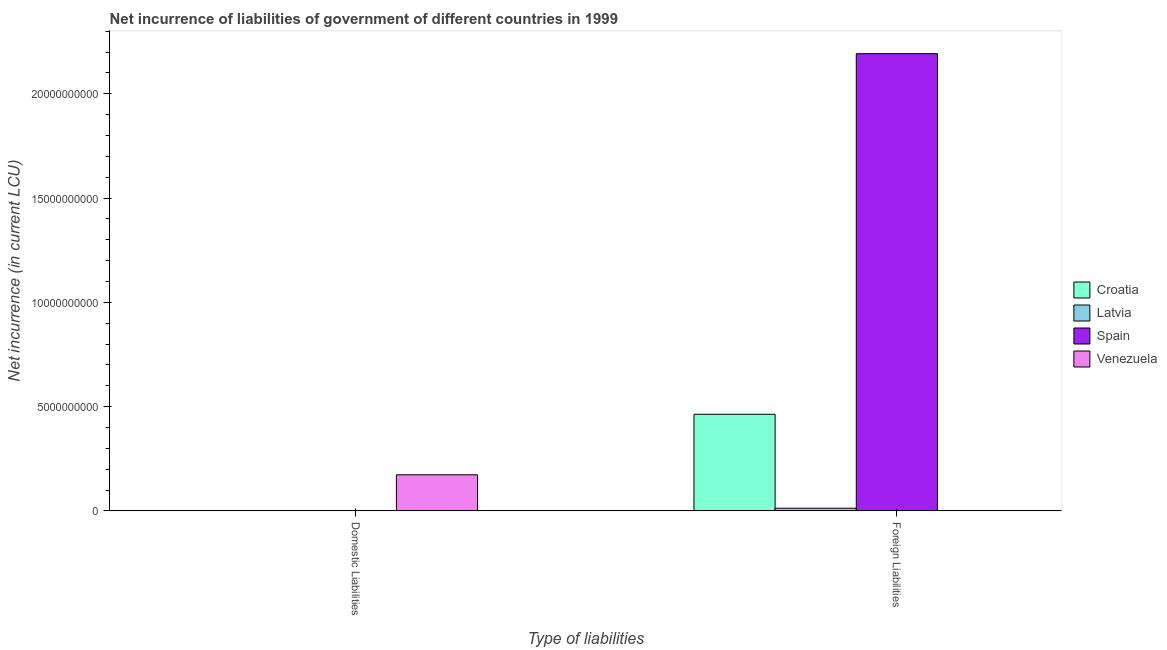How many different coloured bars are there?
Offer a very short reply. 4. Are the number of bars per tick equal to the number of legend labels?
Provide a succinct answer. No. What is the label of the 2nd group of bars from the left?
Your answer should be very brief. Foreign Liabilities. What is the net incurrence of foreign liabilities in Spain?
Provide a short and direct response. 2.19e+1. Across all countries, what is the maximum net incurrence of foreign liabilities?
Your answer should be compact. 2.19e+1. In which country was the net incurrence of domestic liabilities maximum?
Offer a very short reply. Venezuela. What is the total net incurrence of domestic liabilities in the graph?
Your answer should be very brief. 1.73e+09. What is the difference between the net incurrence of foreign liabilities in Latvia and that in Croatia?
Offer a very short reply. -4.50e+09. What is the difference between the net incurrence of domestic liabilities in Venezuela and the net incurrence of foreign liabilities in Spain?
Offer a very short reply. -2.02e+1. What is the average net incurrence of domestic liabilities per country?
Keep it short and to the point. 4.33e+08. In how many countries, is the net incurrence of foreign liabilities greater than 12000000000 LCU?
Your answer should be compact. 1. What is the ratio of the net incurrence of foreign liabilities in Croatia to that in Latvia?
Your answer should be compact. 36.35. Is the net incurrence of foreign liabilities in Latvia less than that in Spain?
Ensure brevity in your answer.  Yes. How many bars are there?
Provide a short and direct response. 4. How many countries are there in the graph?
Offer a terse response. 4. Are the values on the major ticks of Y-axis written in scientific E-notation?
Give a very brief answer. No. How are the legend labels stacked?
Your answer should be very brief. Vertical. What is the title of the graph?
Offer a very short reply. Net incurrence of liabilities of government of different countries in 1999. What is the label or title of the X-axis?
Your answer should be compact. Type of liabilities. What is the label or title of the Y-axis?
Make the answer very short. Net incurrence (in current LCU). What is the Net incurrence (in current LCU) of Croatia in Domestic Liabilities?
Provide a short and direct response. 0. What is the Net incurrence (in current LCU) of Spain in Domestic Liabilities?
Provide a short and direct response. 0. What is the Net incurrence (in current LCU) of Venezuela in Domestic Liabilities?
Ensure brevity in your answer.  1.73e+09. What is the Net incurrence (in current LCU) of Croatia in Foreign Liabilities?
Provide a short and direct response. 4.63e+09. What is the Net incurrence (in current LCU) in Latvia in Foreign Liabilities?
Your response must be concise. 1.27e+08. What is the Net incurrence (in current LCU) of Spain in Foreign Liabilities?
Make the answer very short. 2.19e+1. Across all Type of liabilities, what is the maximum Net incurrence (in current LCU) in Croatia?
Offer a very short reply. 4.63e+09. Across all Type of liabilities, what is the maximum Net incurrence (in current LCU) in Latvia?
Provide a short and direct response. 1.27e+08. Across all Type of liabilities, what is the maximum Net incurrence (in current LCU) in Spain?
Give a very brief answer. 2.19e+1. Across all Type of liabilities, what is the maximum Net incurrence (in current LCU) of Venezuela?
Your response must be concise. 1.73e+09. Across all Type of liabilities, what is the minimum Net incurrence (in current LCU) of Croatia?
Offer a very short reply. 0. Across all Type of liabilities, what is the minimum Net incurrence (in current LCU) in Spain?
Your response must be concise. 0. What is the total Net incurrence (in current LCU) in Croatia in the graph?
Provide a short and direct response. 4.63e+09. What is the total Net incurrence (in current LCU) in Latvia in the graph?
Provide a succinct answer. 1.27e+08. What is the total Net incurrence (in current LCU) of Spain in the graph?
Offer a terse response. 2.19e+1. What is the total Net incurrence (in current LCU) of Venezuela in the graph?
Your answer should be compact. 1.73e+09. What is the average Net incurrence (in current LCU) of Croatia per Type of liabilities?
Your answer should be very brief. 2.32e+09. What is the average Net incurrence (in current LCU) of Latvia per Type of liabilities?
Give a very brief answer. 6.37e+07. What is the average Net incurrence (in current LCU) of Spain per Type of liabilities?
Keep it short and to the point. 1.10e+1. What is the average Net incurrence (in current LCU) of Venezuela per Type of liabilities?
Provide a succinct answer. 8.65e+08. What is the difference between the Net incurrence (in current LCU) in Croatia and Net incurrence (in current LCU) in Latvia in Foreign Liabilities?
Your answer should be compact. 4.50e+09. What is the difference between the Net incurrence (in current LCU) of Croatia and Net incurrence (in current LCU) of Spain in Foreign Liabilities?
Make the answer very short. -1.73e+1. What is the difference between the Net incurrence (in current LCU) in Latvia and Net incurrence (in current LCU) in Spain in Foreign Liabilities?
Provide a short and direct response. -2.18e+1. What is the difference between the highest and the lowest Net incurrence (in current LCU) of Croatia?
Keep it short and to the point. 4.63e+09. What is the difference between the highest and the lowest Net incurrence (in current LCU) in Latvia?
Keep it short and to the point. 1.27e+08. What is the difference between the highest and the lowest Net incurrence (in current LCU) in Spain?
Your answer should be very brief. 2.19e+1. What is the difference between the highest and the lowest Net incurrence (in current LCU) of Venezuela?
Provide a short and direct response. 1.73e+09. 